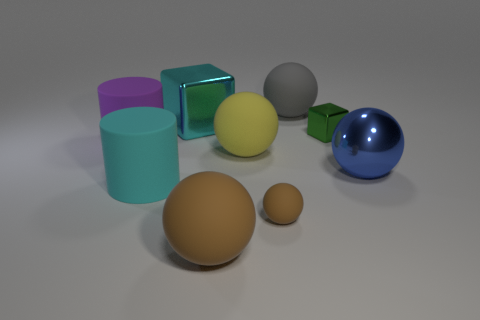Subtract all blue balls. How many balls are left? 4 Subtract all red balls. Subtract all cyan cylinders. How many balls are left? 5 Add 1 big green metallic cylinders. How many objects exist? 10 Subtract all cylinders. How many objects are left? 7 Add 9 yellow matte things. How many yellow matte things are left? 10 Add 8 large blue cylinders. How many large blue cylinders exist? 8 Subtract 0 gray blocks. How many objects are left? 9 Subtract all large cyan balls. Subtract all big metal spheres. How many objects are left? 8 